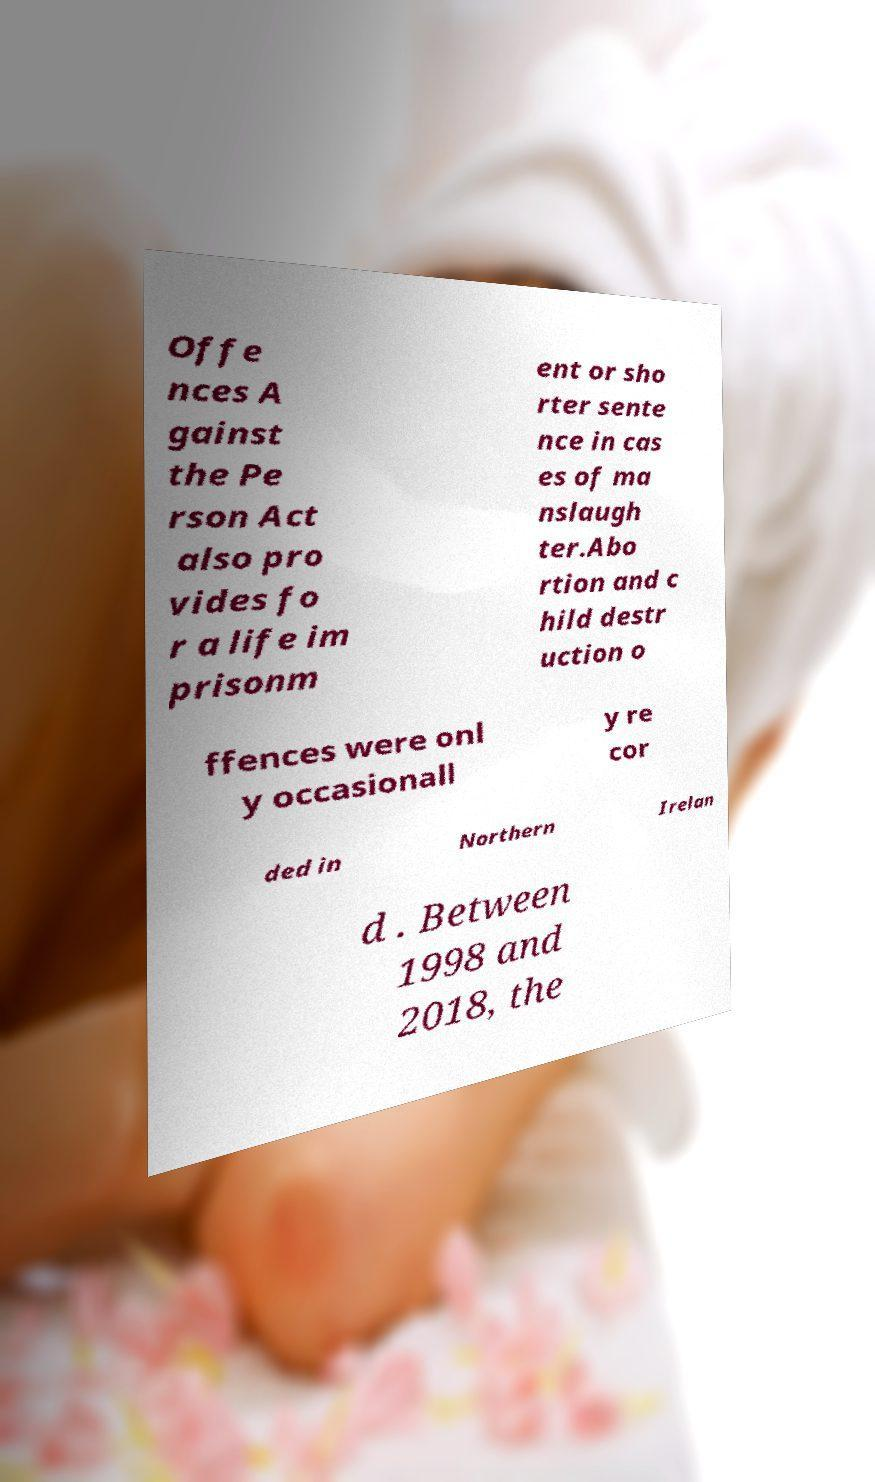I need the written content from this picture converted into text. Can you do that? Offe nces A gainst the Pe rson Act also pro vides fo r a life im prisonm ent or sho rter sente nce in cas es of ma nslaugh ter.Abo rtion and c hild destr uction o ffences were onl y occasionall y re cor ded in Northern Irelan d . Between 1998 and 2018, the 